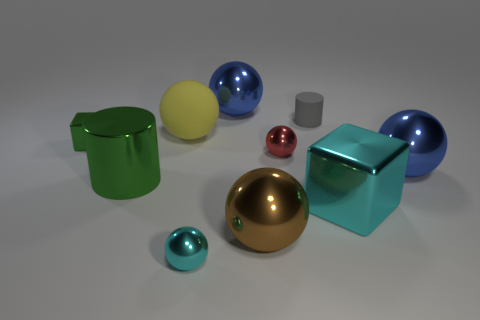What is the material of the cylinder that is to the right of the red metallic ball?
Offer a very short reply. Rubber. Are there the same number of cyan balls behind the large cyan shiny thing and gray matte objects?
Provide a short and direct response. No. Is the small rubber thing the same shape as the yellow object?
Ensure brevity in your answer.  No. Is there anything else of the same color as the rubber cylinder?
Your response must be concise. No. What shape is the big object that is to the right of the big yellow object and behind the green metallic cube?
Provide a succinct answer. Sphere. Are there an equal number of big cyan blocks in front of the tiny cyan ball and tiny cylinders in front of the tiny matte cylinder?
Keep it short and to the point. Yes. What number of spheres are red metal objects or large matte things?
Ensure brevity in your answer.  2. How many tiny cylinders have the same material as the yellow sphere?
Your response must be concise. 1. The tiny metal thing that is the same color as the large shiny cube is what shape?
Offer a very short reply. Sphere. There is a big object that is in front of the shiny cylinder and on the left side of the gray rubber cylinder; what is its material?
Keep it short and to the point. Metal. 